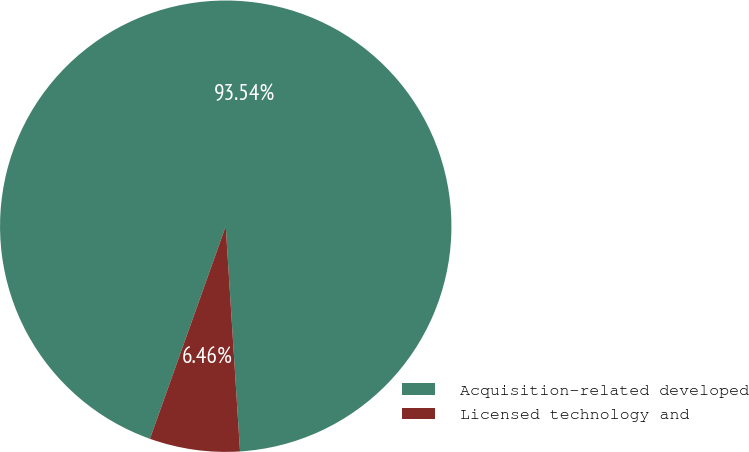<chart> <loc_0><loc_0><loc_500><loc_500><pie_chart><fcel>Acquisition-related developed<fcel>Licensed technology and<nl><fcel>93.54%<fcel>6.46%<nl></chart> 